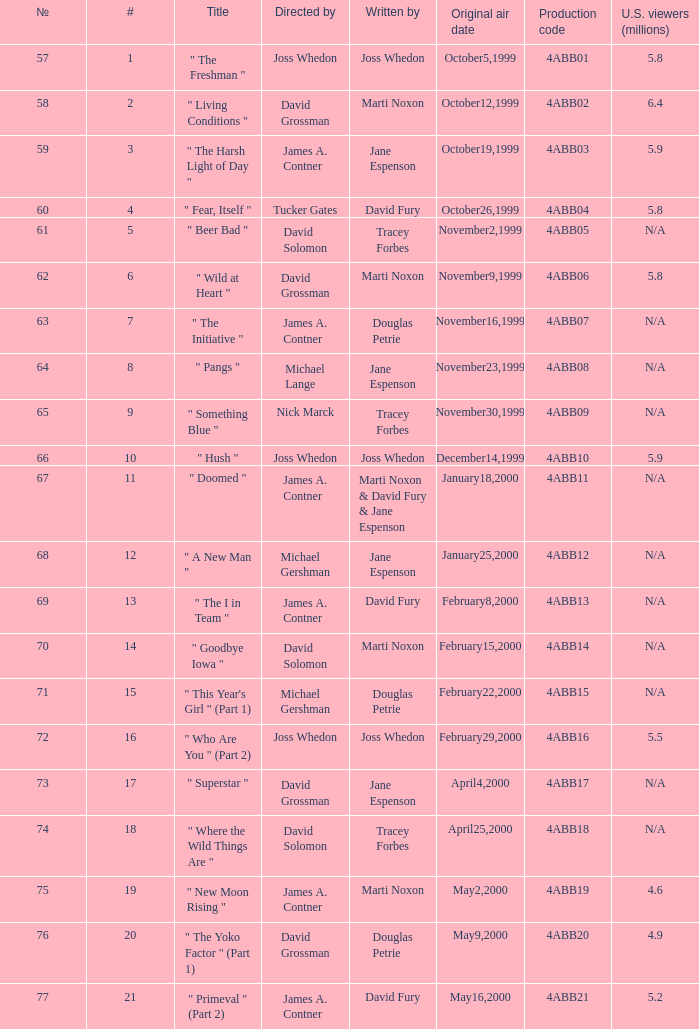What is the series No when the season 4 # is 18? 74.0. 